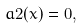<formula> <loc_0><loc_0><loc_500><loc_500>a 2 ( x ) = 0 ,</formula> 